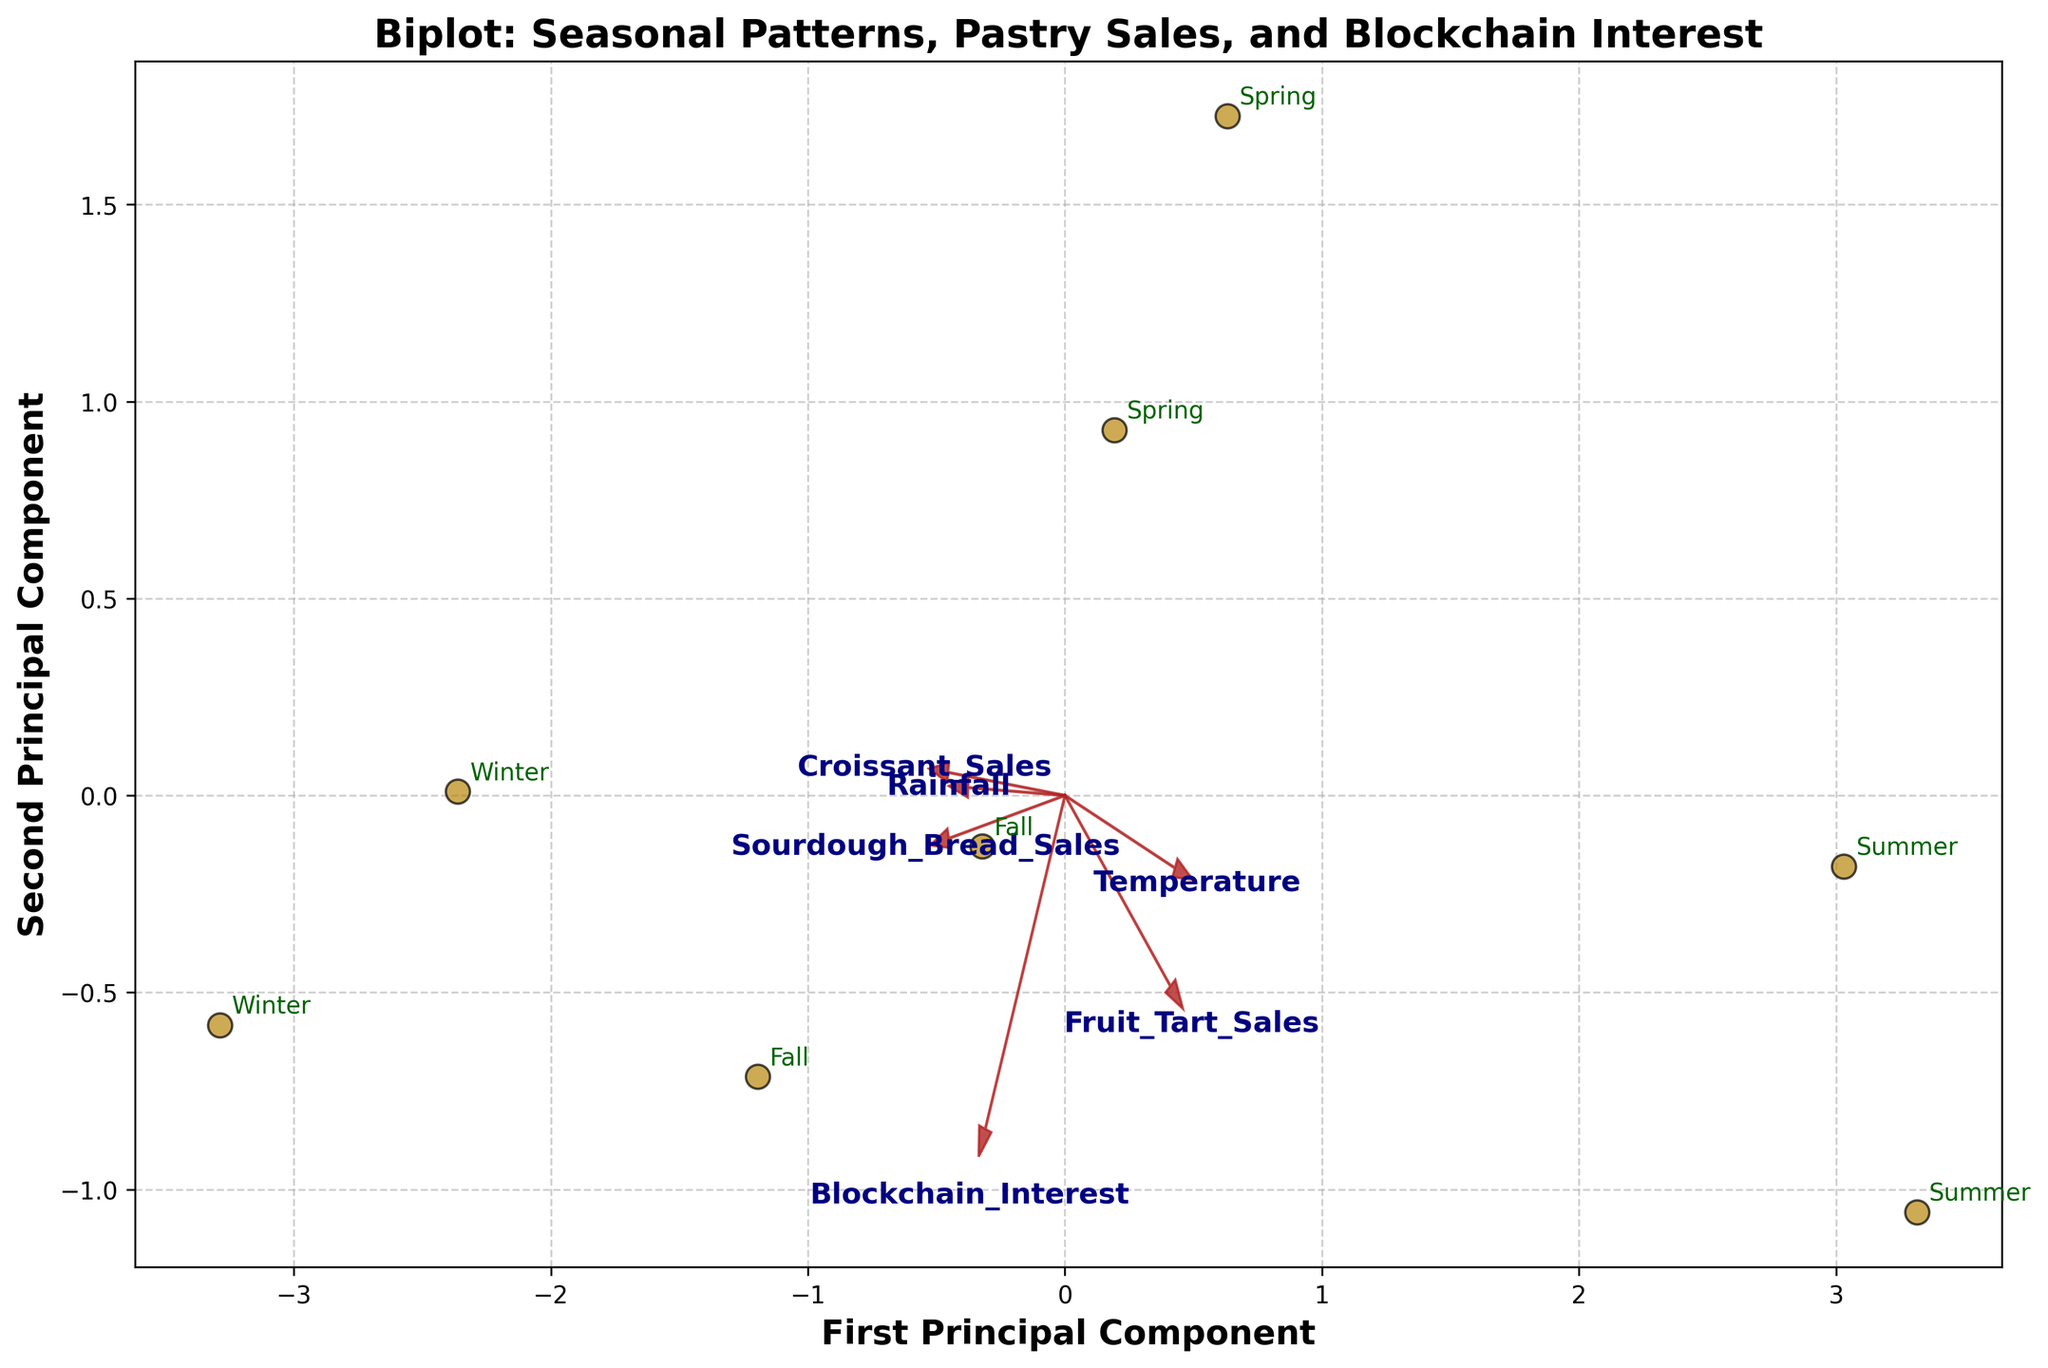Which season corresponds to the data point in the first quadrant closest to the origin? First, identify the first quadrant (top right). Locate the data point closest to the origin in this quadrant. From the plot annotations, this data point corresponds to "Summer."
Answer: Summer What variable is represented by the vector pointing mostly to the right? Identify the vector with the longest horizontal component pointing right. This arrow is labeled with "Fruit_Tart_Sales."
Answer: Fruit_Tart_Sales How does Croissant Sales relate to Temperature based on the biplot vectors? Look at the directions of the vectors for both "Croissant_Sales" and "Temperature." They both point in the same direction, indicating a positive correlation.
Answer: Positively correlated Which two variables appear to be most negatively correlated? Find vectors pointing in roughly opposite directions. The vectors for "Temperature" and "Sourdough_Bread_Sales" point in almost opposite directions.
Answer: Temperature and Sourdough_Bread_Sales Compare Blockchain Interest related vectors for different seasons. Which season shows the highest Blockchain Interest as a data point? Look at the annotation for the season closest to the vector for "Blockchain_Interest." The "Winter" points are closest to this vector, indicating the highest Blockchain Interest during Winter.
Answer: Winter 